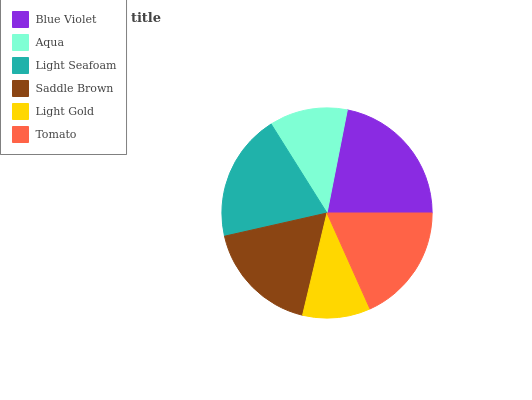Is Light Gold the minimum?
Answer yes or no. Yes. Is Blue Violet the maximum?
Answer yes or no. Yes. Is Aqua the minimum?
Answer yes or no. No. Is Aqua the maximum?
Answer yes or no. No. Is Blue Violet greater than Aqua?
Answer yes or no. Yes. Is Aqua less than Blue Violet?
Answer yes or no. Yes. Is Aqua greater than Blue Violet?
Answer yes or no. No. Is Blue Violet less than Aqua?
Answer yes or no. No. Is Tomato the high median?
Answer yes or no. Yes. Is Saddle Brown the low median?
Answer yes or no. Yes. Is Aqua the high median?
Answer yes or no. No. Is Light Seafoam the low median?
Answer yes or no. No. 